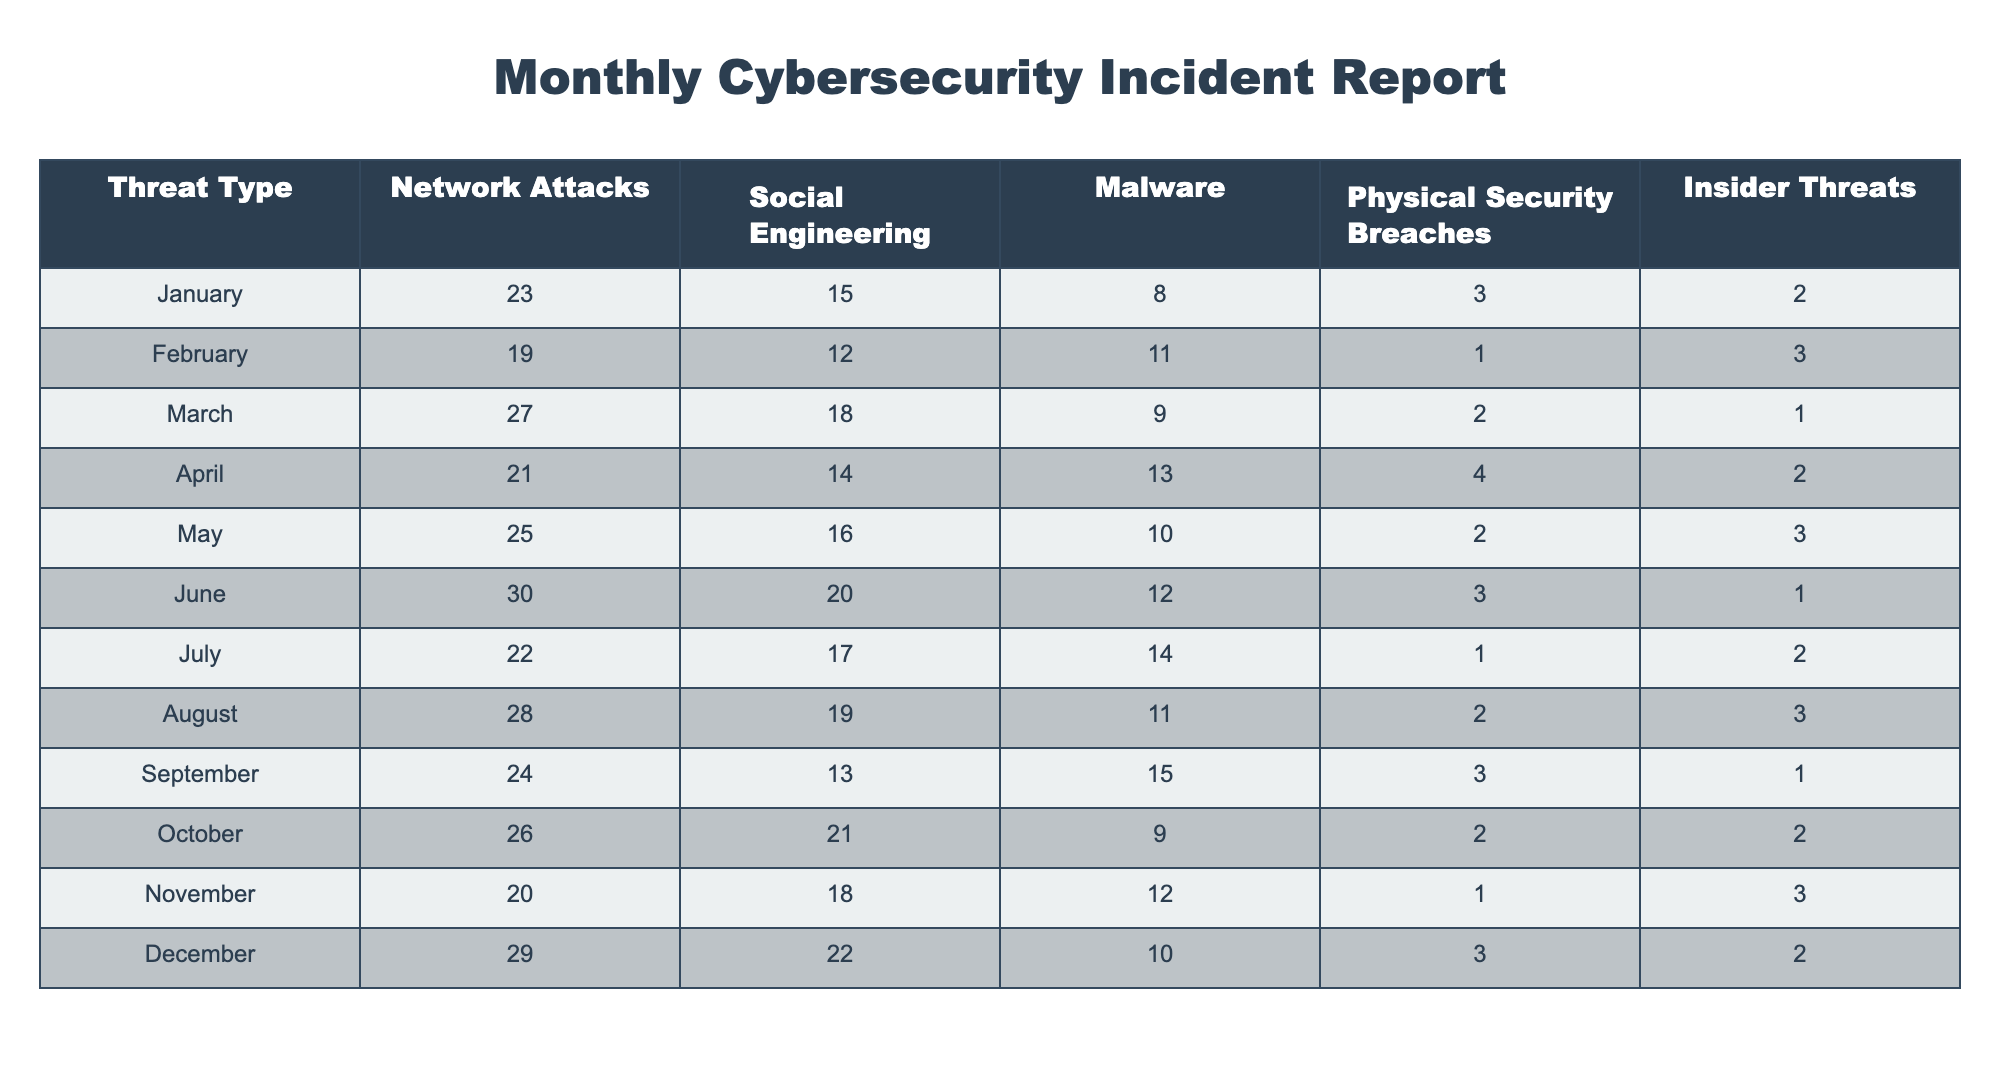What month had the highest number of network attacks? To find the month with the highest number of network attacks, I will look at the "Network Attacks" column and identify the maximum value. The highest value is 30, which occurred in June.
Answer: June What was the total number of physical security breaches for the year? I will sum the values in the "Physical Security Breaches" column for all months: 3 + 1 + 2 + 4 + 2 + 3 + 1 + 2 + 3 + 1 + 3 + 3 = 28.
Answer: 28 Which threat type had the highest count in December? In December, the counts for each threat type are: Network Attacks 29, Social Engineering 22, Malware 10, Physical Security Breaches 3, Insider Threats 2. The highest is 29 for Network Attacks.
Answer: Network Attacks Was there an increase or decrease in insider threats from February to March? In February, insider threats totaled 3, while in March they fell to 1. Therefore, there was a decrease.
Answer: Decrease What is the average number of malware incidents for the second half of the year? The second half includes July (14), August (11), September (15), October (9), November (12), and December (10). I will sum these values (14 + 11 + 15 + 9 + 12 + 10 = 71) and divide by 6 to get the average: 71 / 6 = 11.83.
Answer: 11.83 Which month recorded the least number of social engineering incidents? By checking the "Social Engineering" column, February has the lowest count of 12.
Answer: February Did the number of network attacks increase in October compared to September? In October, the number of network attacks was 26, while in September it was 24. Since 26 > 24, it indicates an increase.
Answer: Yes What was the difference in malware incidents from April to August? April had 13 malware incidents, while August had 11. The difference is calculated by subtracting August from April: 13 - 11 = 2.
Answer: 2 In which month did insider threats peak and what was the value? Referring to the "Insider Threats" column, the month with the highest count is May with a total of 3 incidents.
Answer: May: 3 